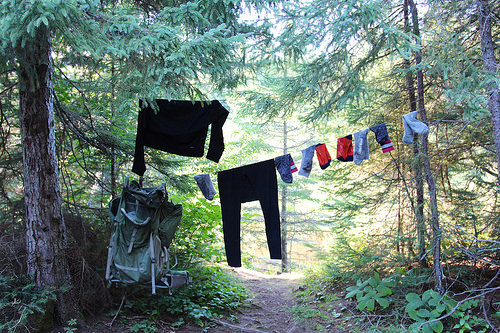<image>
Is there a cloth to the left of the tree? Yes. From this viewpoint, the cloth is positioned to the left side relative to the tree. 